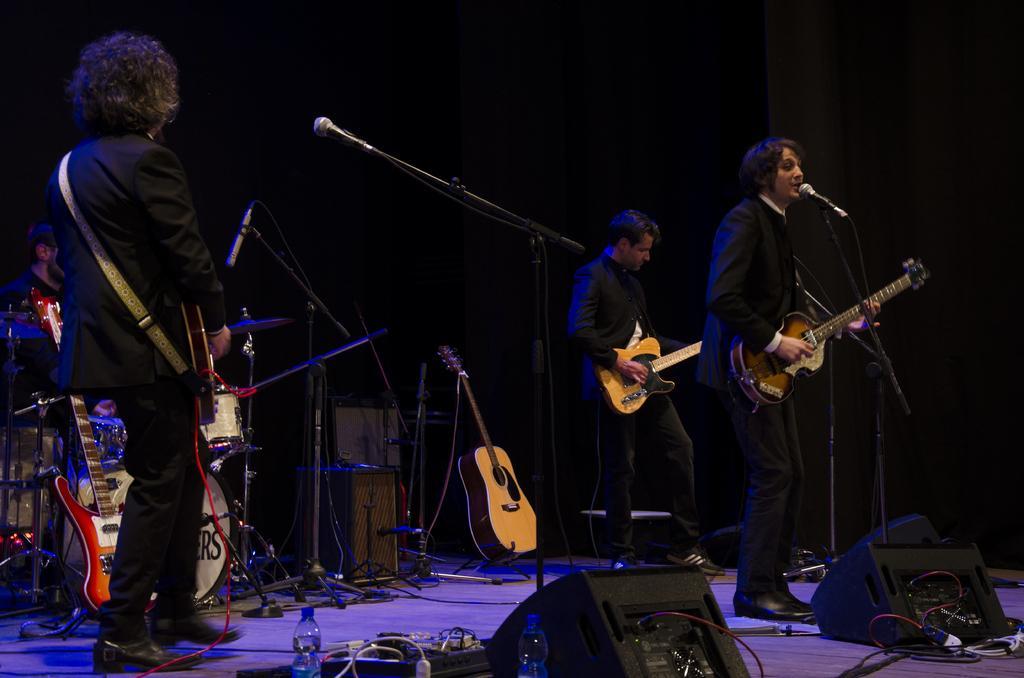How would you summarize this image in a sentence or two? Here we can see a band who is performing on the stage, these guys have guitars in their hand and they are playing them and each and every body is having microphone in front of them and the guy at the front is singing and the guy at the left is playing drums 